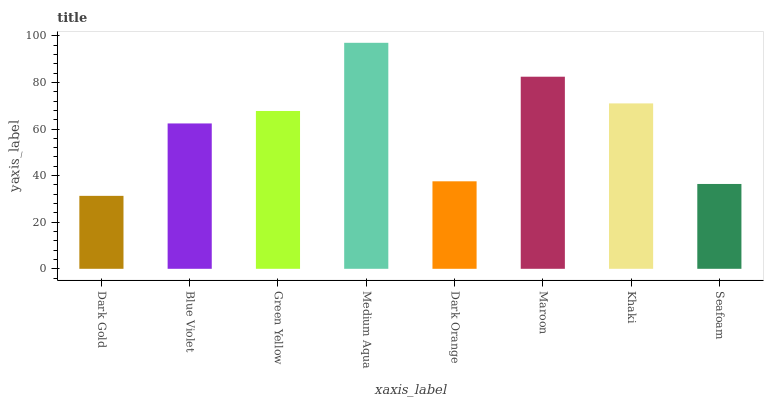Is Dark Gold the minimum?
Answer yes or no. Yes. Is Medium Aqua the maximum?
Answer yes or no. Yes. Is Blue Violet the minimum?
Answer yes or no. No. Is Blue Violet the maximum?
Answer yes or no. No. Is Blue Violet greater than Dark Gold?
Answer yes or no. Yes. Is Dark Gold less than Blue Violet?
Answer yes or no. Yes. Is Dark Gold greater than Blue Violet?
Answer yes or no. No. Is Blue Violet less than Dark Gold?
Answer yes or no. No. Is Green Yellow the high median?
Answer yes or no. Yes. Is Blue Violet the low median?
Answer yes or no. Yes. Is Dark Orange the high median?
Answer yes or no. No. Is Seafoam the low median?
Answer yes or no. No. 